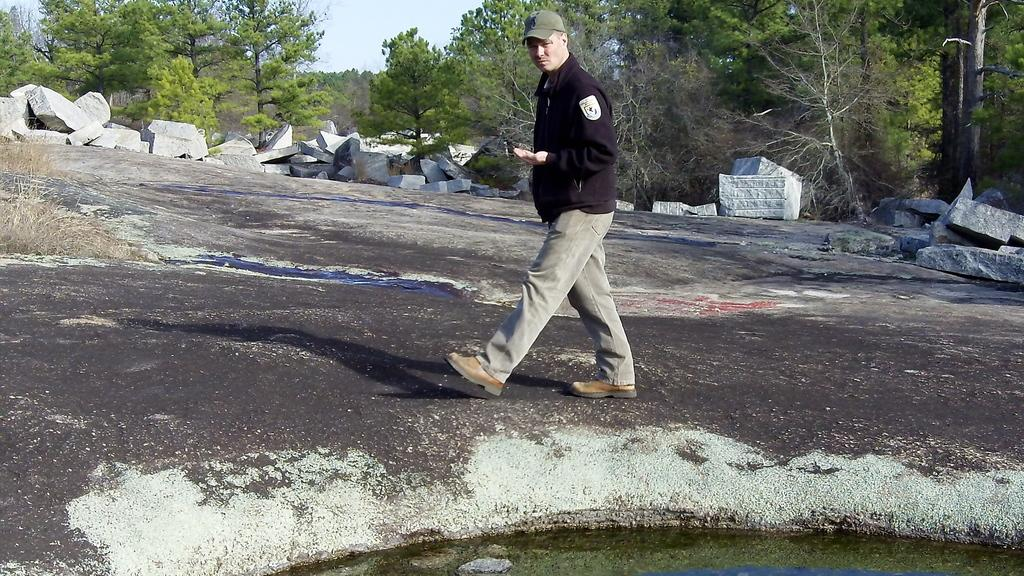What is the man in the image doing? The man is walking in the image. What type of terrain can be seen in the image? There are stones visible in the image. What type of vegetation is present in the image? There are trees in the image. What is at the bottom of the image? There is water at the bottom of the image. How many owls can be seen in the image? There are no owls present in the image. What type of appliance is being used by the man in the image? There is no appliance visible in the image. 